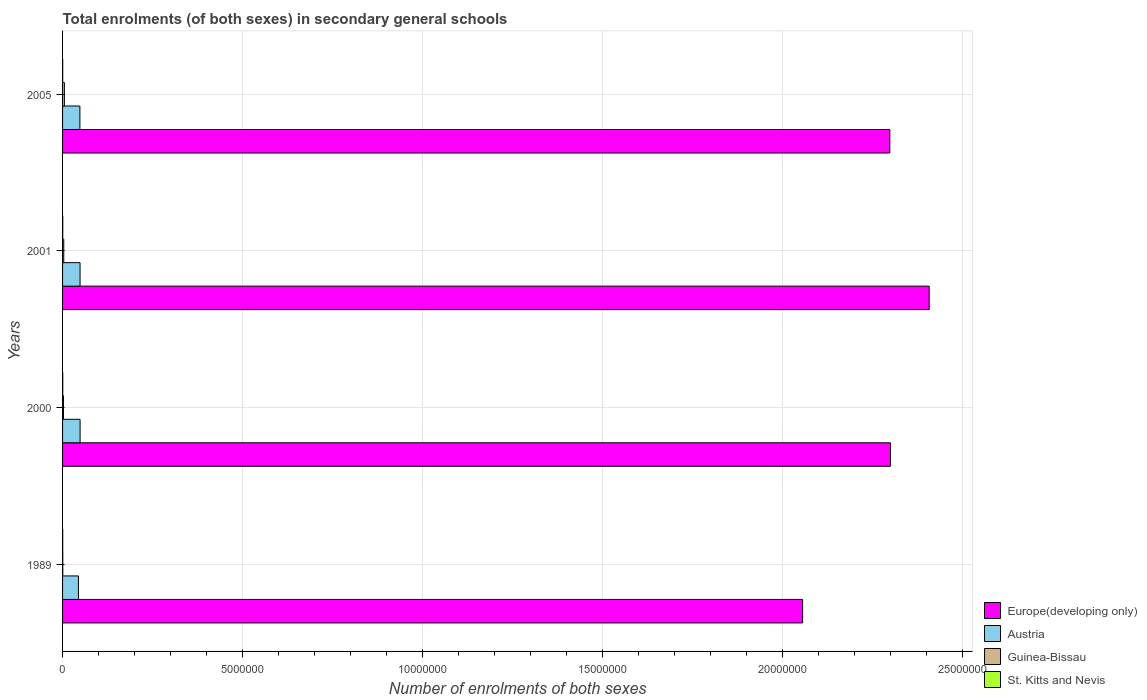How many different coloured bars are there?
Provide a short and direct response. 4. Are the number of bars per tick equal to the number of legend labels?
Your answer should be compact. Yes. Are the number of bars on each tick of the Y-axis equal?
Offer a terse response. Yes. How many bars are there on the 1st tick from the top?
Give a very brief answer. 4. In how many cases, is the number of bars for a given year not equal to the number of legend labels?
Offer a very short reply. 0. What is the number of enrolments in secondary schools in Guinea-Bissau in 2005?
Your response must be concise. 5.05e+04. Across all years, what is the maximum number of enrolments in secondary schools in St. Kitts and Nevis?
Offer a very short reply. 4768. Across all years, what is the minimum number of enrolments in secondary schools in Europe(developing only)?
Make the answer very short. 2.06e+07. In which year was the number of enrolments in secondary schools in St. Kitts and Nevis maximum?
Make the answer very short. 2000. In which year was the number of enrolments in secondary schools in Europe(developing only) minimum?
Keep it short and to the point. 1989. What is the total number of enrolments in secondary schools in St. Kitts and Nevis in the graph?
Provide a short and direct response. 1.75e+04. What is the difference between the number of enrolments in secondary schools in Guinea-Bissau in 1989 and that in 2001?
Offer a terse response. -2.75e+04. What is the difference between the number of enrolments in secondary schools in Europe(developing only) in 2005 and the number of enrolments in secondary schools in Guinea-Bissau in 2001?
Ensure brevity in your answer.  2.30e+07. What is the average number of enrolments in secondary schools in Guinea-Bissau per year?
Your response must be concise. 2.85e+04. In the year 2005, what is the difference between the number of enrolments in secondary schools in Austria and number of enrolments in secondary schools in St. Kitts and Nevis?
Offer a terse response. 4.77e+05. What is the ratio of the number of enrolments in secondary schools in Guinea-Bissau in 2000 to that in 2005?
Your answer should be compact. 0.49. Is the number of enrolments in secondary schools in St. Kitts and Nevis in 1989 less than that in 2000?
Provide a short and direct response. Yes. What is the difference between the highest and the second highest number of enrolments in secondary schools in Austria?
Provide a short and direct response. 883. What is the difference between the highest and the lowest number of enrolments in secondary schools in Guinea-Bissau?
Make the answer very short. 4.50e+04. Is it the case that in every year, the sum of the number of enrolments in secondary schools in Europe(developing only) and number of enrolments in secondary schools in Guinea-Bissau is greater than the sum of number of enrolments in secondary schools in St. Kitts and Nevis and number of enrolments in secondary schools in Austria?
Provide a succinct answer. Yes. What does the 1st bar from the top in 2000 represents?
Make the answer very short. St. Kitts and Nevis. What does the 3rd bar from the bottom in 1989 represents?
Offer a terse response. Guinea-Bissau. Is it the case that in every year, the sum of the number of enrolments in secondary schools in Guinea-Bissau and number of enrolments in secondary schools in Europe(developing only) is greater than the number of enrolments in secondary schools in Austria?
Provide a succinct answer. Yes. Are all the bars in the graph horizontal?
Offer a terse response. Yes. How many years are there in the graph?
Offer a very short reply. 4. Are the values on the major ticks of X-axis written in scientific E-notation?
Your answer should be compact. No. Does the graph contain any zero values?
Offer a very short reply. No. Where does the legend appear in the graph?
Offer a very short reply. Bottom right. How many legend labels are there?
Your response must be concise. 4. What is the title of the graph?
Ensure brevity in your answer.  Total enrolments (of both sexes) in secondary general schools. What is the label or title of the X-axis?
Ensure brevity in your answer.  Number of enrolments of both sexes. What is the Number of enrolments of both sexes of Europe(developing only) in 1989?
Keep it short and to the point. 2.06e+07. What is the Number of enrolments of both sexes in Austria in 1989?
Your answer should be very brief. 4.41e+05. What is the Number of enrolments of both sexes of Guinea-Bissau in 1989?
Make the answer very short. 5505. What is the Number of enrolments of both sexes in St. Kitts and Nevis in 1989?
Your answer should be compact. 4204. What is the Number of enrolments of both sexes in Europe(developing only) in 2000?
Make the answer very short. 2.30e+07. What is the Number of enrolments of both sexes in Austria in 2000?
Your response must be concise. 4.87e+05. What is the Number of enrolments of both sexes of Guinea-Bissau in 2000?
Keep it short and to the point. 2.49e+04. What is the Number of enrolments of both sexes in St. Kitts and Nevis in 2000?
Provide a short and direct response. 4768. What is the Number of enrolments of both sexes in Europe(developing only) in 2001?
Offer a very short reply. 2.41e+07. What is the Number of enrolments of both sexes of Austria in 2001?
Offer a very short reply. 4.86e+05. What is the Number of enrolments of both sexes of Guinea-Bissau in 2001?
Your response must be concise. 3.30e+04. What is the Number of enrolments of both sexes in St. Kitts and Nevis in 2001?
Offer a very short reply. 4623. What is the Number of enrolments of both sexes of Europe(developing only) in 2005?
Offer a very short reply. 2.30e+07. What is the Number of enrolments of both sexes of Austria in 2005?
Provide a succinct answer. 4.81e+05. What is the Number of enrolments of both sexes in Guinea-Bissau in 2005?
Provide a succinct answer. 5.05e+04. What is the Number of enrolments of both sexes of St. Kitts and Nevis in 2005?
Give a very brief answer. 3939. Across all years, what is the maximum Number of enrolments of both sexes in Europe(developing only)?
Offer a terse response. 2.41e+07. Across all years, what is the maximum Number of enrolments of both sexes of Austria?
Your answer should be very brief. 4.87e+05. Across all years, what is the maximum Number of enrolments of both sexes in Guinea-Bissau?
Offer a terse response. 5.05e+04. Across all years, what is the maximum Number of enrolments of both sexes in St. Kitts and Nevis?
Your response must be concise. 4768. Across all years, what is the minimum Number of enrolments of both sexes in Europe(developing only)?
Provide a short and direct response. 2.06e+07. Across all years, what is the minimum Number of enrolments of both sexes of Austria?
Make the answer very short. 4.41e+05. Across all years, what is the minimum Number of enrolments of both sexes in Guinea-Bissau?
Your answer should be compact. 5505. Across all years, what is the minimum Number of enrolments of both sexes in St. Kitts and Nevis?
Provide a short and direct response. 3939. What is the total Number of enrolments of both sexes in Europe(developing only) in the graph?
Offer a very short reply. 9.07e+07. What is the total Number of enrolments of both sexes in Austria in the graph?
Your answer should be compact. 1.90e+06. What is the total Number of enrolments of both sexes of Guinea-Bissau in the graph?
Offer a terse response. 1.14e+05. What is the total Number of enrolments of both sexes of St. Kitts and Nevis in the graph?
Keep it short and to the point. 1.75e+04. What is the difference between the Number of enrolments of both sexes of Europe(developing only) in 1989 and that in 2000?
Keep it short and to the point. -2.44e+06. What is the difference between the Number of enrolments of both sexes in Austria in 1989 and that in 2000?
Offer a terse response. -4.58e+04. What is the difference between the Number of enrolments of both sexes of Guinea-Bissau in 1989 and that in 2000?
Your answer should be very brief. -1.94e+04. What is the difference between the Number of enrolments of both sexes in St. Kitts and Nevis in 1989 and that in 2000?
Ensure brevity in your answer.  -564. What is the difference between the Number of enrolments of both sexes of Europe(developing only) in 1989 and that in 2001?
Your answer should be compact. -3.52e+06. What is the difference between the Number of enrolments of both sexes in Austria in 1989 and that in 2001?
Your response must be concise. -4.49e+04. What is the difference between the Number of enrolments of both sexes of Guinea-Bissau in 1989 and that in 2001?
Your answer should be compact. -2.75e+04. What is the difference between the Number of enrolments of both sexes in St. Kitts and Nevis in 1989 and that in 2001?
Offer a very short reply. -419. What is the difference between the Number of enrolments of both sexes in Europe(developing only) in 1989 and that in 2005?
Provide a short and direct response. -2.42e+06. What is the difference between the Number of enrolments of both sexes of Austria in 1989 and that in 2005?
Your answer should be compact. -4.01e+04. What is the difference between the Number of enrolments of both sexes of Guinea-Bissau in 1989 and that in 2005?
Your answer should be compact. -4.50e+04. What is the difference between the Number of enrolments of both sexes in St. Kitts and Nevis in 1989 and that in 2005?
Your response must be concise. 265. What is the difference between the Number of enrolments of both sexes of Europe(developing only) in 2000 and that in 2001?
Your answer should be compact. -1.08e+06. What is the difference between the Number of enrolments of both sexes in Austria in 2000 and that in 2001?
Offer a terse response. 883. What is the difference between the Number of enrolments of both sexes of Guinea-Bissau in 2000 and that in 2001?
Ensure brevity in your answer.  -8054. What is the difference between the Number of enrolments of both sexes of St. Kitts and Nevis in 2000 and that in 2001?
Provide a succinct answer. 145. What is the difference between the Number of enrolments of both sexes in Europe(developing only) in 2000 and that in 2005?
Offer a very short reply. 1.68e+04. What is the difference between the Number of enrolments of both sexes in Austria in 2000 and that in 2005?
Keep it short and to the point. 5613. What is the difference between the Number of enrolments of both sexes of Guinea-Bissau in 2000 and that in 2005?
Your answer should be very brief. -2.56e+04. What is the difference between the Number of enrolments of both sexes of St. Kitts and Nevis in 2000 and that in 2005?
Provide a short and direct response. 829. What is the difference between the Number of enrolments of both sexes of Europe(developing only) in 2001 and that in 2005?
Provide a succinct answer. 1.09e+06. What is the difference between the Number of enrolments of both sexes of Austria in 2001 and that in 2005?
Keep it short and to the point. 4730. What is the difference between the Number of enrolments of both sexes of Guinea-Bissau in 2001 and that in 2005?
Make the answer very short. -1.75e+04. What is the difference between the Number of enrolments of both sexes in St. Kitts and Nevis in 2001 and that in 2005?
Provide a short and direct response. 684. What is the difference between the Number of enrolments of both sexes in Europe(developing only) in 1989 and the Number of enrolments of both sexes in Austria in 2000?
Make the answer very short. 2.01e+07. What is the difference between the Number of enrolments of both sexes of Europe(developing only) in 1989 and the Number of enrolments of both sexes of Guinea-Bissau in 2000?
Keep it short and to the point. 2.05e+07. What is the difference between the Number of enrolments of both sexes of Europe(developing only) in 1989 and the Number of enrolments of both sexes of St. Kitts and Nevis in 2000?
Offer a very short reply. 2.06e+07. What is the difference between the Number of enrolments of both sexes in Austria in 1989 and the Number of enrolments of both sexes in Guinea-Bissau in 2000?
Your response must be concise. 4.16e+05. What is the difference between the Number of enrolments of both sexes in Austria in 1989 and the Number of enrolments of both sexes in St. Kitts and Nevis in 2000?
Give a very brief answer. 4.36e+05. What is the difference between the Number of enrolments of both sexes in Guinea-Bissau in 1989 and the Number of enrolments of both sexes in St. Kitts and Nevis in 2000?
Provide a succinct answer. 737. What is the difference between the Number of enrolments of both sexes of Europe(developing only) in 1989 and the Number of enrolments of both sexes of Austria in 2001?
Provide a short and direct response. 2.01e+07. What is the difference between the Number of enrolments of both sexes in Europe(developing only) in 1989 and the Number of enrolments of both sexes in Guinea-Bissau in 2001?
Give a very brief answer. 2.05e+07. What is the difference between the Number of enrolments of both sexes of Europe(developing only) in 1989 and the Number of enrolments of both sexes of St. Kitts and Nevis in 2001?
Offer a terse response. 2.06e+07. What is the difference between the Number of enrolments of both sexes of Austria in 1989 and the Number of enrolments of both sexes of Guinea-Bissau in 2001?
Give a very brief answer. 4.08e+05. What is the difference between the Number of enrolments of both sexes in Austria in 1989 and the Number of enrolments of both sexes in St. Kitts and Nevis in 2001?
Your response must be concise. 4.37e+05. What is the difference between the Number of enrolments of both sexes in Guinea-Bissau in 1989 and the Number of enrolments of both sexes in St. Kitts and Nevis in 2001?
Provide a short and direct response. 882. What is the difference between the Number of enrolments of both sexes of Europe(developing only) in 1989 and the Number of enrolments of both sexes of Austria in 2005?
Make the answer very short. 2.01e+07. What is the difference between the Number of enrolments of both sexes in Europe(developing only) in 1989 and the Number of enrolments of both sexes in Guinea-Bissau in 2005?
Give a very brief answer. 2.05e+07. What is the difference between the Number of enrolments of both sexes of Europe(developing only) in 1989 and the Number of enrolments of both sexes of St. Kitts and Nevis in 2005?
Your answer should be compact. 2.06e+07. What is the difference between the Number of enrolments of both sexes in Austria in 1989 and the Number of enrolments of both sexes in Guinea-Bissau in 2005?
Offer a very short reply. 3.91e+05. What is the difference between the Number of enrolments of both sexes in Austria in 1989 and the Number of enrolments of both sexes in St. Kitts and Nevis in 2005?
Your response must be concise. 4.37e+05. What is the difference between the Number of enrolments of both sexes of Guinea-Bissau in 1989 and the Number of enrolments of both sexes of St. Kitts and Nevis in 2005?
Your answer should be compact. 1566. What is the difference between the Number of enrolments of both sexes of Europe(developing only) in 2000 and the Number of enrolments of both sexes of Austria in 2001?
Keep it short and to the point. 2.25e+07. What is the difference between the Number of enrolments of both sexes of Europe(developing only) in 2000 and the Number of enrolments of both sexes of Guinea-Bissau in 2001?
Offer a terse response. 2.30e+07. What is the difference between the Number of enrolments of both sexes of Europe(developing only) in 2000 and the Number of enrolments of both sexes of St. Kitts and Nevis in 2001?
Give a very brief answer. 2.30e+07. What is the difference between the Number of enrolments of both sexes in Austria in 2000 and the Number of enrolments of both sexes in Guinea-Bissau in 2001?
Give a very brief answer. 4.54e+05. What is the difference between the Number of enrolments of both sexes in Austria in 2000 and the Number of enrolments of both sexes in St. Kitts and Nevis in 2001?
Keep it short and to the point. 4.82e+05. What is the difference between the Number of enrolments of both sexes in Guinea-Bissau in 2000 and the Number of enrolments of both sexes in St. Kitts and Nevis in 2001?
Your response must be concise. 2.03e+04. What is the difference between the Number of enrolments of both sexes in Europe(developing only) in 2000 and the Number of enrolments of both sexes in Austria in 2005?
Provide a succinct answer. 2.25e+07. What is the difference between the Number of enrolments of both sexes of Europe(developing only) in 2000 and the Number of enrolments of both sexes of Guinea-Bissau in 2005?
Your answer should be very brief. 2.30e+07. What is the difference between the Number of enrolments of both sexes of Europe(developing only) in 2000 and the Number of enrolments of both sexes of St. Kitts and Nevis in 2005?
Make the answer very short. 2.30e+07. What is the difference between the Number of enrolments of both sexes of Austria in 2000 and the Number of enrolments of both sexes of Guinea-Bissau in 2005?
Keep it short and to the point. 4.36e+05. What is the difference between the Number of enrolments of both sexes in Austria in 2000 and the Number of enrolments of both sexes in St. Kitts and Nevis in 2005?
Provide a short and direct response. 4.83e+05. What is the difference between the Number of enrolments of both sexes in Guinea-Bissau in 2000 and the Number of enrolments of both sexes in St. Kitts and Nevis in 2005?
Offer a very short reply. 2.10e+04. What is the difference between the Number of enrolments of both sexes of Europe(developing only) in 2001 and the Number of enrolments of both sexes of Austria in 2005?
Your answer should be very brief. 2.36e+07. What is the difference between the Number of enrolments of both sexes in Europe(developing only) in 2001 and the Number of enrolments of both sexes in Guinea-Bissau in 2005?
Offer a terse response. 2.40e+07. What is the difference between the Number of enrolments of both sexes in Europe(developing only) in 2001 and the Number of enrolments of both sexes in St. Kitts and Nevis in 2005?
Give a very brief answer. 2.41e+07. What is the difference between the Number of enrolments of both sexes in Austria in 2001 and the Number of enrolments of both sexes in Guinea-Bissau in 2005?
Keep it short and to the point. 4.36e+05. What is the difference between the Number of enrolments of both sexes of Austria in 2001 and the Number of enrolments of both sexes of St. Kitts and Nevis in 2005?
Your answer should be very brief. 4.82e+05. What is the difference between the Number of enrolments of both sexes in Guinea-Bissau in 2001 and the Number of enrolments of both sexes in St. Kitts and Nevis in 2005?
Make the answer very short. 2.90e+04. What is the average Number of enrolments of both sexes of Europe(developing only) per year?
Your answer should be compact. 2.27e+07. What is the average Number of enrolments of both sexes in Austria per year?
Make the answer very short. 4.74e+05. What is the average Number of enrolments of both sexes of Guinea-Bissau per year?
Provide a short and direct response. 2.85e+04. What is the average Number of enrolments of both sexes in St. Kitts and Nevis per year?
Provide a succinct answer. 4383.5. In the year 1989, what is the difference between the Number of enrolments of both sexes of Europe(developing only) and Number of enrolments of both sexes of Austria?
Offer a very short reply. 2.01e+07. In the year 1989, what is the difference between the Number of enrolments of both sexes in Europe(developing only) and Number of enrolments of both sexes in Guinea-Bissau?
Your response must be concise. 2.06e+07. In the year 1989, what is the difference between the Number of enrolments of both sexes in Europe(developing only) and Number of enrolments of both sexes in St. Kitts and Nevis?
Your answer should be compact. 2.06e+07. In the year 1989, what is the difference between the Number of enrolments of both sexes of Austria and Number of enrolments of both sexes of Guinea-Bissau?
Provide a short and direct response. 4.36e+05. In the year 1989, what is the difference between the Number of enrolments of both sexes in Austria and Number of enrolments of both sexes in St. Kitts and Nevis?
Your answer should be compact. 4.37e+05. In the year 1989, what is the difference between the Number of enrolments of both sexes of Guinea-Bissau and Number of enrolments of both sexes of St. Kitts and Nevis?
Keep it short and to the point. 1301. In the year 2000, what is the difference between the Number of enrolments of both sexes of Europe(developing only) and Number of enrolments of both sexes of Austria?
Provide a short and direct response. 2.25e+07. In the year 2000, what is the difference between the Number of enrolments of both sexes of Europe(developing only) and Number of enrolments of both sexes of Guinea-Bissau?
Your response must be concise. 2.30e+07. In the year 2000, what is the difference between the Number of enrolments of both sexes of Europe(developing only) and Number of enrolments of both sexes of St. Kitts and Nevis?
Provide a short and direct response. 2.30e+07. In the year 2000, what is the difference between the Number of enrolments of both sexes of Austria and Number of enrolments of both sexes of Guinea-Bissau?
Offer a terse response. 4.62e+05. In the year 2000, what is the difference between the Number of enrolments of both sexes in Austria and Number of enrolments of both sexes in St. Kitts and Nevis?
Your answer should be compact. 4.82e+05. In the year 2000, what is the difference between the Number of enrolments of both sexes of Guinea-Bissau and Number of enrolments of both sexes of St. Kitts and Nevis?
Your answer should be compact. 2.01e+04. In the year 2001, what is the difference between the Number of enrolments of both sexes of Europe(developing only) and Number of enrolments of both sexes of Austria?
Your response must be concise. 2.36e+07. In the year 2001, what is the difference between the Number of enrolments of both sexes of Europe(developing only) and Number of enrolments of both sexes of Guinea-Bissau?
Offer a terse response. 2.41e+07. In the year 2001, what is the difference between the Number of enrolments of both sexes of Europe(developing only) and Number of enrolments of both sexes of St. Kitts and Nevis?
Give a very brief answer. 2.41e+07. In the year 2001, what is the difference between the Number of enrolments of both sexes in Austria and Number of enrolments of both sexes in Guinea-Bissau?
Your answer should be very brief. 4.53e+05. In the year 2001, what is the difference between the Number of enrolments of both sexes of Austria and Number of enrolments of both sexes of St. Kitts and Nevis?
Your answer should be compact. 4.81e+05. In the year 2001, what is the difference between the Number of enrolments of both sexes in Guinea-Bissau and Number of enrolments of both sexes in St. Kitts and Nevis?
Make the answer very short. 2.83e+04. In the year 2005, what is the difference between the Number of enrolments of both sexes of Europe(developing only) and Number of enrolments of both sexes of Austria?
Make the answer very short. 2.25e+07. In the year 2005, what is the difference between the Number of enrolments of both sexes of Europe(developing only) and Number of enrolments of both sexes of Guinea-Bissau?
Offer a very short reply. 2.29e+07. In the year 2005, what is the difference between the Number of enrolments of both sexes of Europe(developing only) and Number of enrolments of both sexes of St. Kitts and Nevis?
Ensure brevity in your answer.  2.30e+07. In the year 2005, what is the difference between the Number of enrolments of both sexes in Austria and Number of enrolments of both sexes in Guinea-Bissau?
Make the answer very short. 4.31e+05. In the year 2005, what is the difference between the Number of enrolments of both sexes of Austria and Number of enrolments of both sexes of St. Kitts and Nevis?
Make the answer very short. 4.77e+05. In the year 2005, what is the difference between the Number of enrolments of both sexes in Guinea-Bissau and Number of enrolments of both sexes in St. Kitts and Nevis?
Give a very brief answer. 4.66e+04. What is the ratio of the Number of enrolments of both sexes of Europe(developing only) in 1989 to that in 2000?
Offer a terse response. 0.89. What is the ratio of the Number of enrolments of both sexes in Austria in 1989 to that in 2000?
Offer a terse response. 0.91. What is the ratio of the Number of enrolments of both sexes of Guinea-Bissau in 1989 to that in 2000?
Offer a terse response. 0.22. What is the ratio of the Number of enrolments of both sexes in St. Kitts and Nevis in 1989 to that in 2000?
Offer a very short reply. 0.88. What is the ratio of the Number of enrolments of both sexes in Europe(developing only) in 1989 to that in 2001?
Make the answer very short. 0.85. What is the ratio of the Number of enrolments of both sexes in Austria in 1989 to that in 2001?
Keep it short and to the point. 0.91. What is the ratio of the Number of enrolments of both sexes of Guinea-Bissau in 1989 to that in 2001?
Provide a short and direct response. 0.17. What is the ratio of the Number of enrolments of both sexes in St. Kitts and Nevis in 1989 to that in 2001?
Your response must be concise. 0.91. What is the ratio of the Number of enrolments of both sexes in Europe(developing only) in 1989 to that in 2005?
Make the answer very short. 0.89. What is the ratio of the Number of enrolments of both sexes in Austria in 1989 to that in 2005?
Ensure brevity in your answer.  0.92. What is the ratio of the Number of enrolments of both sexes in Guinea-Bissau in 1989 to that in 2005?
Provide a short and direct response. 0.11. What is the ratio of the Number of enrolments of both sexes in St. Kitts and Nevis in 1989 to that in 2005?
Provide a succinct answer. 1.07. What is the ratio of the Number of enrolments of both sexes of Europe(developing only) in 2000 to that in 2001?
Ensure brevity in your answer.  0.96. What is the ratio of the Number of enrolments of both sexes of Guinea-Bissau in 2000 to that in 2001?
Your response must be concise. 0.76. What is the ratio of the Number of enrolments of both sexes in St. Kitts and Nevis in 2000 to that in 2001?
Your response must be concise. 1.03. What is the ratio of the Number of enrolments of both sexes in Europe(developing only) in 2000 to that in 2005?
Provide a succinct answer. 1. What is the ratio of the Number of enrolments of both sexes of Austria in 2000 to that in 2005?
Your answer should be compact. 1.01. What is the ratio of the Number of enrolments of both sexes of Guinea-Bissau in 2000 to that in 2005?
Keep it short and to the point. 0.49. What is the ratio of the Number of enrolments of both sexes in St. Kitts and Nevis in 2000 to that in 2005?
Your answer should be very brief. 1.21. What is the ratio of the Number of enrolments of both sexes in Europe(developing only) in 2001 to that in 2005?
Keep it short and to the point. 1.05. What is the ratio of the Number of enrolments of both sexes of Austria in 2001 to that in 2005?
Offer a very short reply. 1.01. What is the ratio of the Number of enrolments of both sexes in Guinea-Bissau in 2001 to that in 2005?
Provide a succinct answer. 0.65. What is the ratio of the Number of enrolments of both sexes in St. Kitts and Nevis in 2001 to that in 2005?
Offer a terse response. 1.17. What is the difference between the highest and the second highest Number of enrolments of both sexes in Europe(developing only)?
Provide a short and direct response. 1.08e+06. What is the difference between the highest and the second highest Number of enrolments of both sexes of Austria?
Ensure brevity in your answer.  883. What is the difference between the highest and the second highest Number of enrolments of both sexes in Guinea-Bissau?
Ensure brevity in your answer.  1.75e+04. What is the difference between the highest and the second highest Number of enrolments of both sexes in St. Kitts and Nevis?
Ensure brevity in your answer.  145. What is the difference between the highest and the lowest Number of enrolments of both sexes in Europe(developing only)?
Give a very brief answer. 3.52e+06. What is the difference between the highest and the lowest Number of enrolments of both sexes of Austria?
Your answer should be compact. 4.58e+04. What is the difference between the highest and the lowest Number of enrolments of both sexes in Guinea-Bissau?
Ensure brevity in your answer.  4.50e+04. What is the difference between the highest and the lowest Number of enrolments of both sexes of St. Kitts and Nevis?
Keep it short and to the point. 829. 